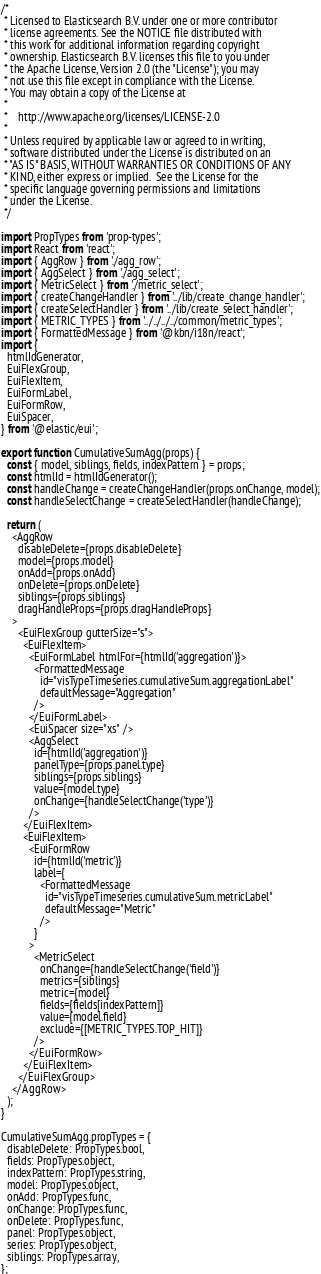<code> <loc_0><loc_0><loc_500><loc_500><_JavaScript_>/*
 * Licensed to Elasticsearch B.V. under one or more contributor
 * license agreements. See the NOTICE file distributed with
 * this work for additional information regarding copyright
 * ownership. Elasticsearch B.V. licenses this file to you under
 * the Apache License, Version 2.0 (the "License"); you may
 * not use this file except in compliance with the License.
 * You may obtain a copy of the License at
 *
 *    http://www.apache.org/licenses/LICENSE-2.0
 *
 * Unless required by applicable law or agreed to in writing,
 * software distributed under the License is distributed on an
 * "AS IS" BASIS, WITHOUT WARRANTIES OR CONDITIONS OF ANY
 * KIND, either express or implied.  See the License for the
 * specific language governing permissions and limitations
 * under the License.
 */

import PropTypes from 'prop-types';
import React from 'react';
import { AggRow } from './agg_row';
import { AggSelect } from './agg_select';
import { MetricSelect } from './metric_select';
import { createChangeHandler } from '../lib/create_change_handler';
import { createSelectHandler } from '../lib/create_select_handler';
import { METRIC_TYPES } from '../../../../common/metric_types';
import { FormattedMessage } from '@kbn/i18n/react';
import {
  htmlIdGenerator,
  EuiFlexGroup,
  EuiFlexItem,
  EuiFormLabel,
  EuiFormRow,
  EuiSpacer,
} from '@elastic/eui';

export function CumulativeSumAgg(props) {
  const { model, siblings, fields, indexPattern } = props;
  const htmlId = htmlIdGenerator();
  const handleChange = createChangeHandler(props.onChange, model);
  const handleSelectChange = createSelectHandler(handleChange);

  return (
    <AggRow
      disableDelete={props.disableDelete}
      model={props.model}
      onAdd={props.onAdd}
      onDelete={props.onDelete}
      siblings={props.siblings}
      dragHandleProps={props.dragHandleProps}
    >
      <EuiFlexGroup gutterSize="s">
        <EuiFlexItem>
          <EuiFormLabel htmlFor={htmlId('aggregation')}>
            <FormattedMessage
              id="visTypeTimeseries.cumulativeSum.aggregationLabel"
              defaultMessage="Aggregation"
            />
          </EuiFormLabel>
          <EuiSpacer size="xs" />
          <AggSelect
            id={htmlId('aggregation')}
            panelType={props.panel.type}
            siblings={props.siblings}
            value={model.type}
            onChange={handleSelectChange('type')}
          />
        </EuiFlexItem>
        <EuiFlexItem>
          <EuiFormRow
            id={htmlId('metric')}
            label={
              <FormattedMessage
                id="visTypeTimeseries.cumulativeSum.metricLabel"
                defaultMessage="Metric"
              />
            }
          >
            <MetricSelect
              onChange={handleSelectChange('field')}
              metrics={siblings}
              metric={model}
              fields={fields[indexPattern]}
              value={model.field}
              exclude={[METRIC_TYPES.TOP_HIT]}
            />
          </EuiFormRow>
        </EuiFlexItem>
      </EuiFlexGroup>
    </AggRow>
  );
}

CumulativeSumAgg.propTypes = {
  disableDelete: PropTypes.bool,
  fields: PropTypes.object,
  indexPattern: PropTypes.string,
  model: PropTypes.object,
  onAdd: PropTypes.func,
  onChange: PropTypes.func,
  onDelete: PropTypes.func,
  panel: PropTypes.object,
  series: PropTypes.object,
  siblings: PropTypes.array,
};
</code> 